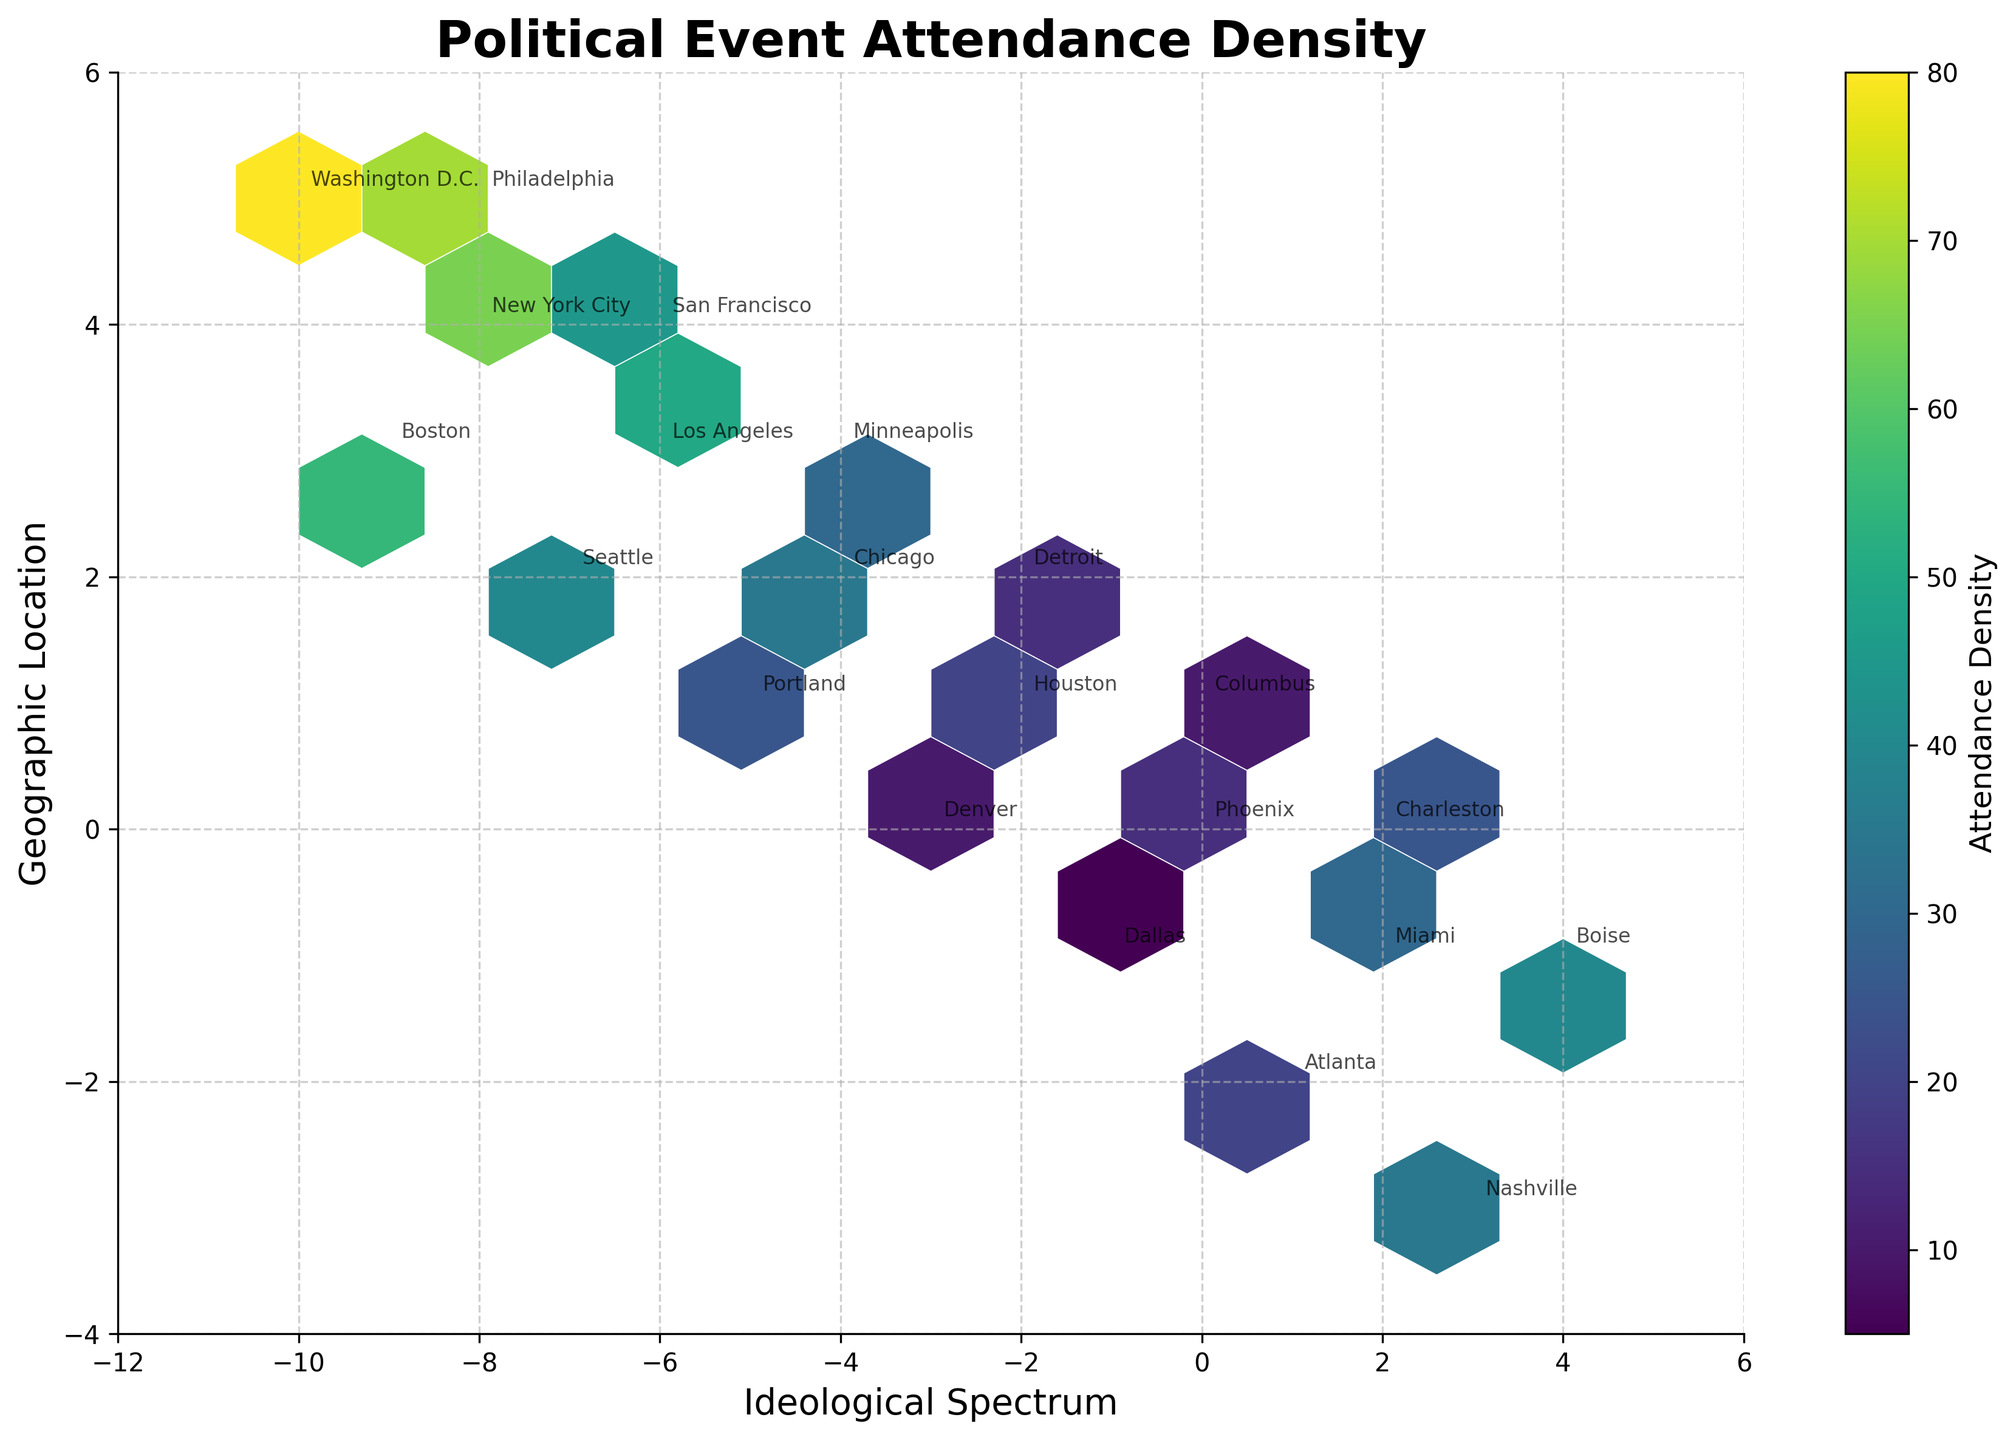What is the title of the plot? The title is usually displayed at the top of the plot and is often in bold or larger font size. In this case, the title "Political Event Attendance Density" is written in bold.
Answer: Political Event Attendance Density How is attendance density represented in the plot? Attendance density is often represented visually, and in this plot, it is shown through color intensity. The hexbin plot uses a color scale where different shades indicate different densities.
Answer: By color intensity What geographic location has the highest density on the far left of the ideological spectrum? On the far left side of the spectrum (negative x-axis), the hex with the most intense color represents the highest density. In the plot, Washington D.C. in the 'Far Left' ideology exhibits the highest density.
Answer: Washington D.C Which city is located at (0, 0) and what is its attendance density? The coordinates (0, 0) identify a specific point on the plot, and by looking at this point, we can see which city label corresponds to it. From the plot, Phoenix is located at (0, 0), and its density value is shown by its color.
Answer: Phoenix, 15 What is the attendance density for the 'Traditionalist' ideology? To find this, locate the 'Traditionalist' label, which corresponds to the coordinates (2, 0). The color intensity of this hex can be matched to the density value through the color bar.
Answer: 25 What's the difference in attendance density between the 'Far Left' (Washington D.C.) and 'Far Right' (Miami) locations? Identify the densities at Washington D.C. and Miami from the plot. The Far Left (Washington D.C.) has a density of 80, and the Far Right (Miami) has a density of 30. Subtract the latter from the former.
Answer: 50 Which two cities located close to each other have different densities, and what are their densities? Look for cities that are near each other on the plot but have different color intensities. San Francisco (at -6, 4) and Los Angeles (at -6, 3) fit this description. Their densities are represented by their colors.
Answer: San Francisco (45) and Los Angeles (50) Which ideological spectrum region has more cities listed: the left (negative x) or right (positive x)? Count the number of cities labeled on the left (negative x-axis) and those on the right (positive x-axis). Compare the counts to determine which side has more cities.
Answer: Left What location is represented by the darkest hexagonal bin in the plot? The darkest bin indicates the highest attendance density. By checking the bin with the darkest color and finding the corresponding annotated label, we locate the city.
Answer: Washington D.C Are there more cities towards the moderate center or towards the extremes of the ideological spectrum? Observe the distribution of labeled cities along the x-axis. Count those near the center and those towards the more extreme ends (Far Left, Far Right). Compare these counts.
Answer: Extremes 